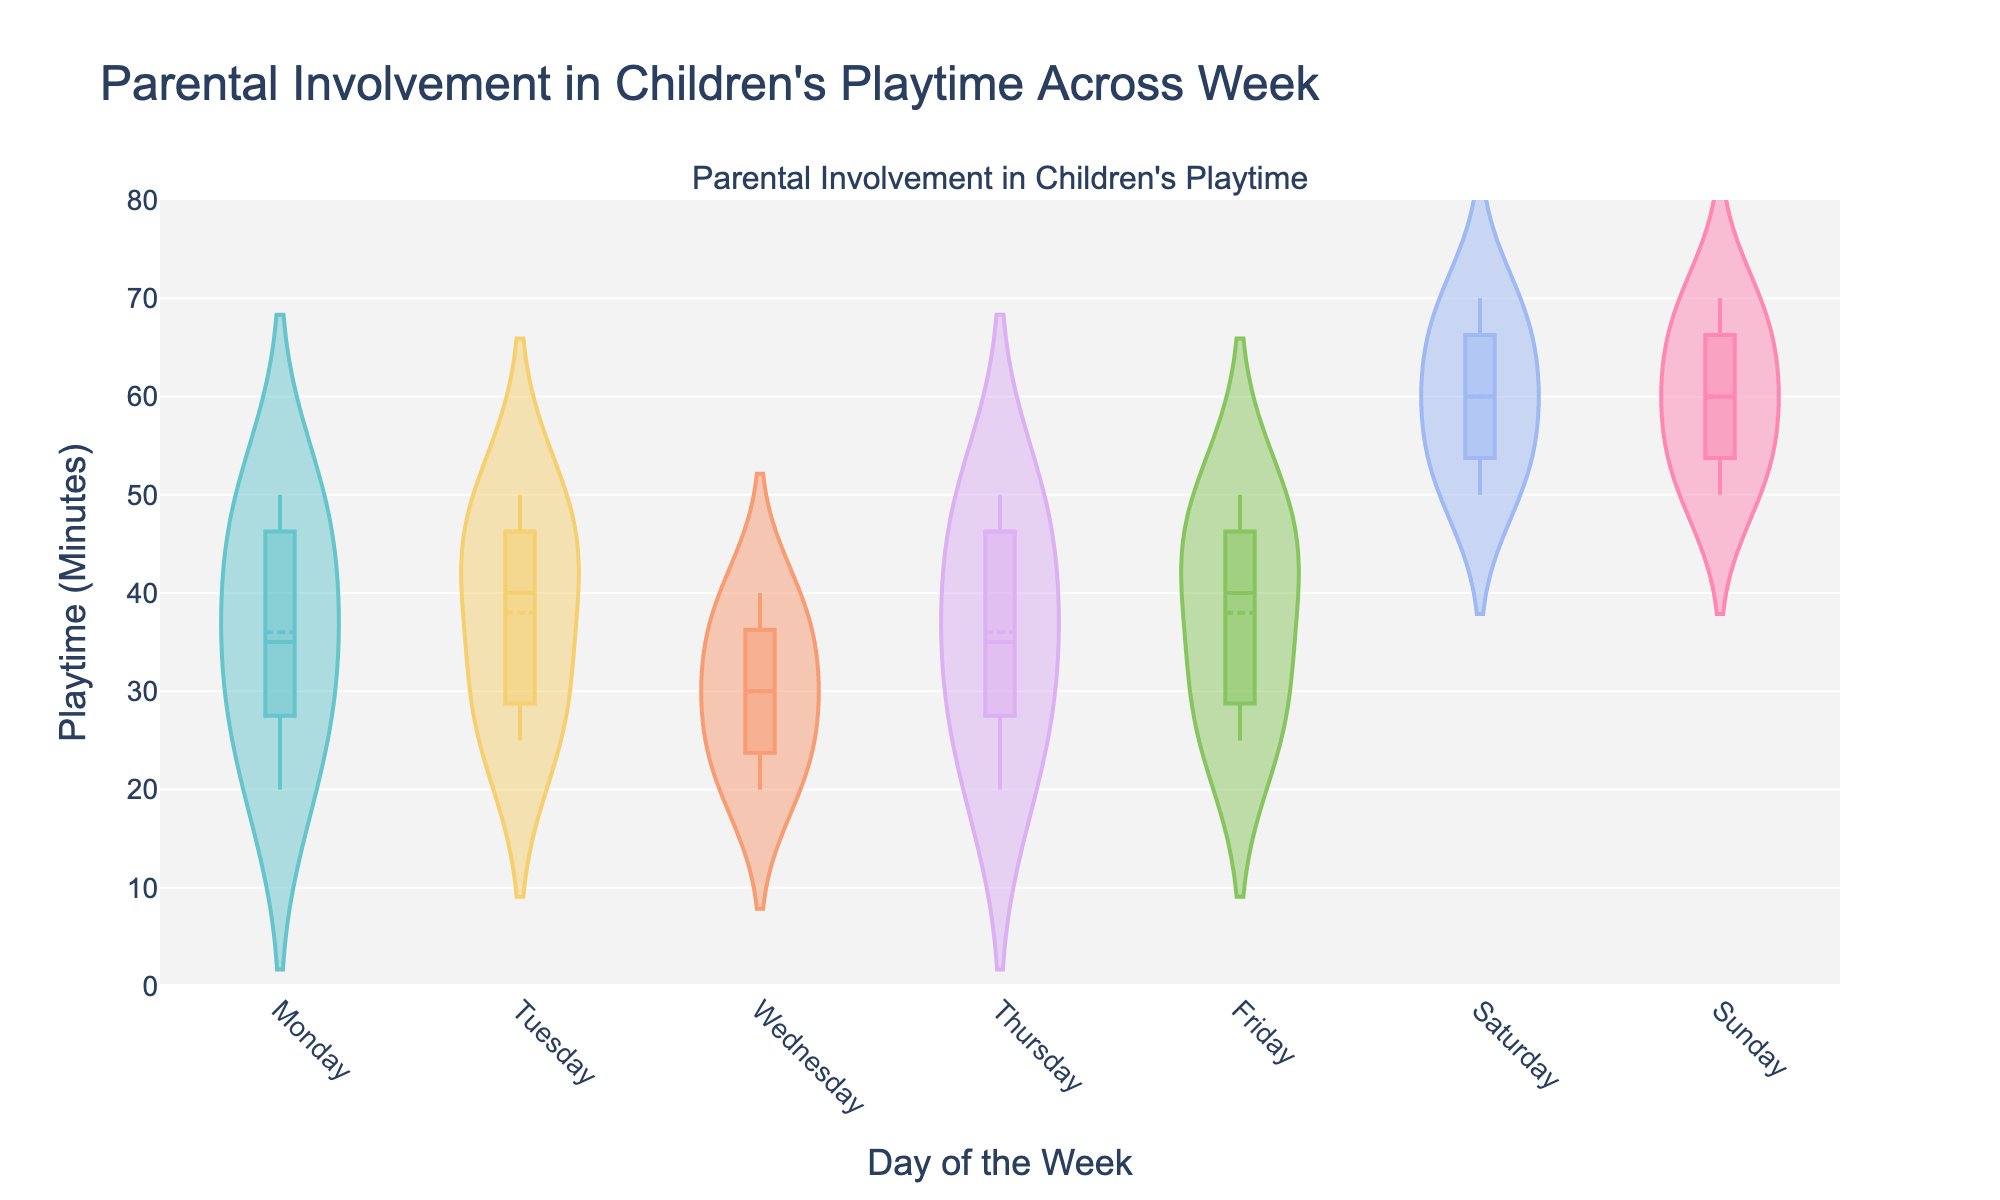what is the title of the figure? The title of the figure is usually displayed prominently at the top, summarizing the main content in a few words. In this case, the title is centered above the plot.
Answer: "Parental Involvement in Children's Playtime Across Week" How many days of the week are represented in the figure? The figure includes all the days from Monday to Sunday, which constitutes a full week. We can tell because there are unique color-coded violin plots for seven different days.
Answer: 7 What is the range of playtime (in minutes) shown on the Y-axis? The Y-axis represents playtime in minutes and is labeled accordingly. By observing the ticks and their spacing on the axis, we can determine the full range.
Answer: 0 to 80 On which day is playtime the most varied? Playtime variation can be judged by the spread of data points in the violin plot. The wider the plot, the more varied. Visually, the plot for Saturday and Sunday appear to have the widest spread.
Answer: Saturday and Sunday Which day has the highest median playtime? The median is indicated by the horizontal line inside each violin plot. By comparing the positions of these lines, we can determine which one is highest above the Y-axis baseline.
Answer: Sunday What is the approximate median playtime on Wednesday? The median playtime is shown as a horizontal line within the violin plot for each day. By reading the position of this line on the Y-axis where Wednesday is located, we can estimate it.
Answer: 30 minutes On which days is the playtime most consistent? Consistency in playtime can be identified by tightly packed plots. Days with narrower violin plots indicate less variation, implying more consistent playtime.
Answer: Wednesday and Friday Compare the playtime distributions of Tuesday and Thursday. Which day has higher variability? Variability can be observed through the spread of the violin plot. Comparing the widths of the plots for Tuesday and Thursday will reveal which one has a broader distribution.
Answer: Thursday Which day has the lowest observed playtime? The lowest observed playtime corresponds to the minimum value that is closest to the Y-axis baseline in any violin plot. Observing all plots, we can identify the lowest point.
Answer: Wednesday and Thursday (20 minutes) 